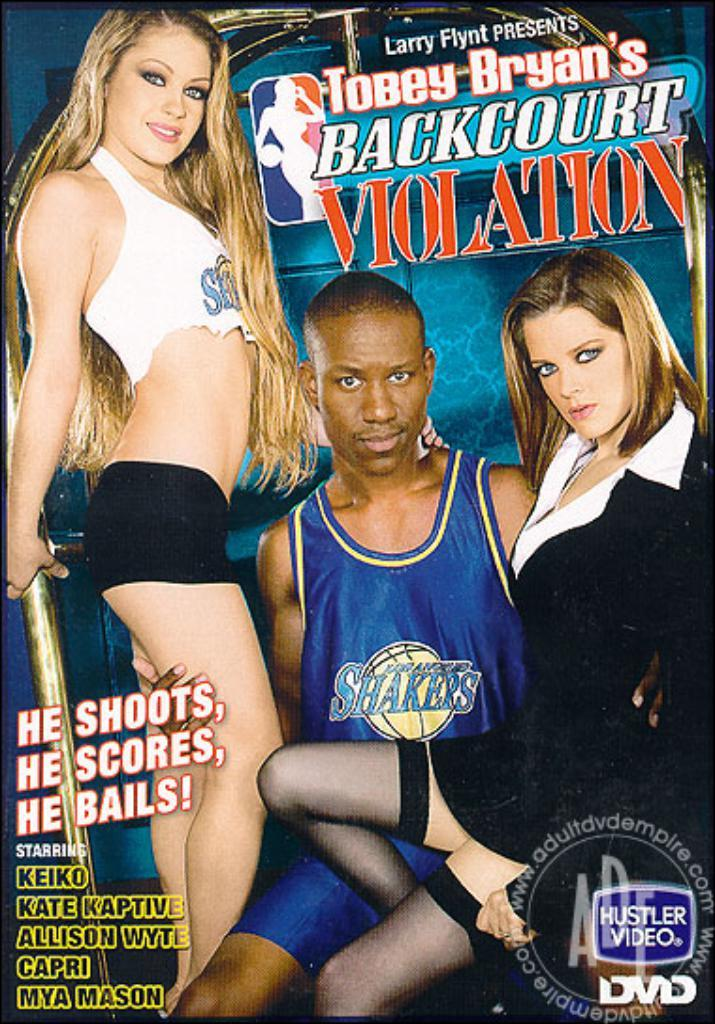Provide a one-sentence caption for the provided image. An advertisement for Backcourt Violation that has a picture of a man and two ladies. 